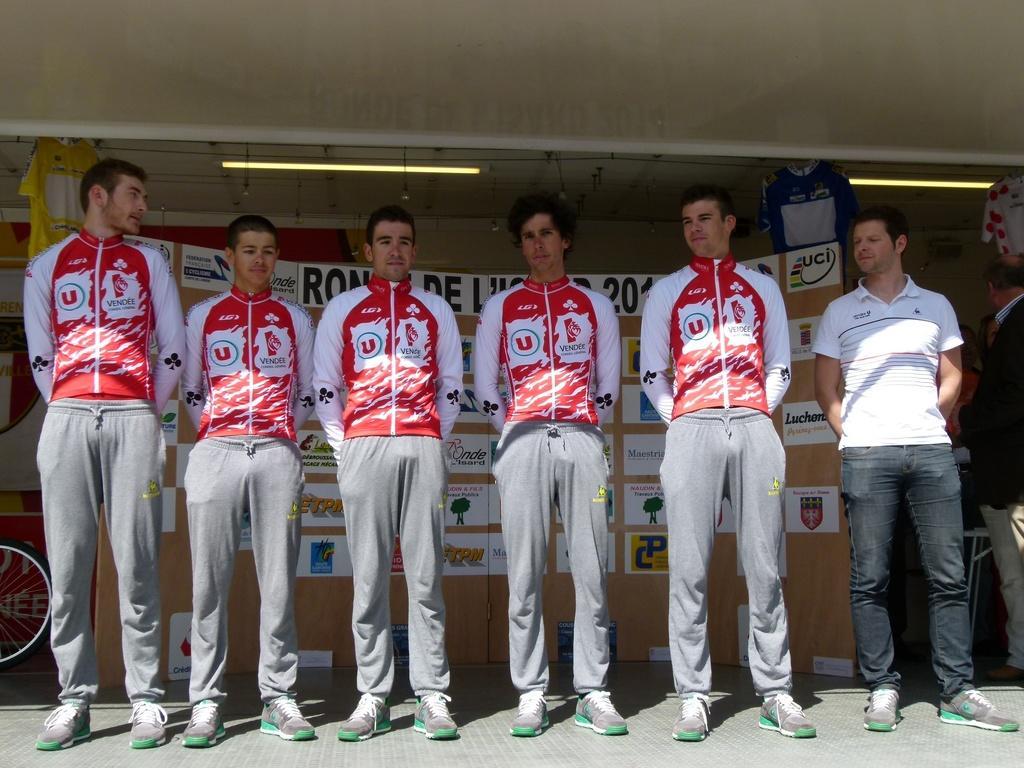Can you describe this image briefly? In this image in the center there are persons standing. In the background there is a banner with some text written on the banner. On the top there are lights hanging and there are T-shirts hanging. On the left side there is a tyre. 